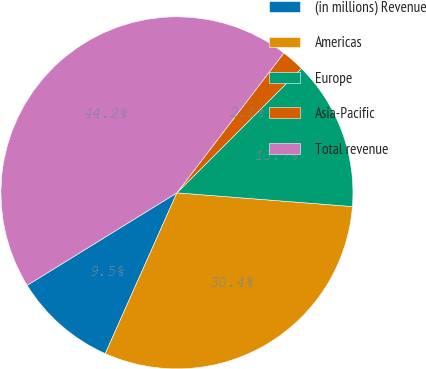Convert chart. <chart><loc_0><loc_0><loc_500><loc_500><pie_chart><fcel>(in millions) Revenue<fcel>Americas<fcel>Europe<fcel>Asia-Pacific<fcel>Total revenue<nl><fcel>9.52%<fcel>30.43%<fcel>13.73%<fcel>2.12%<fcel>44.19%<nl></chart> 